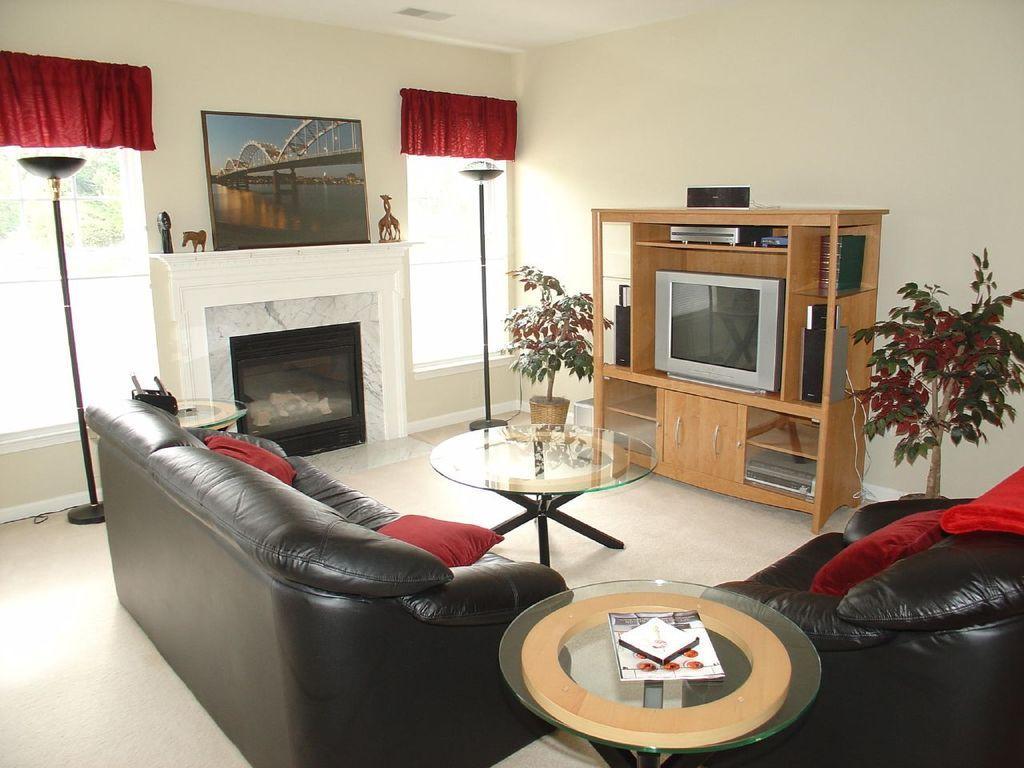Describe this image in one or two sentences. A picture inside of a room. A picture on wall. This is a furniture with television. Beside this furniture there are plants. This is window. These are black couches with red pillows. These are tables, on this table there is a book. 